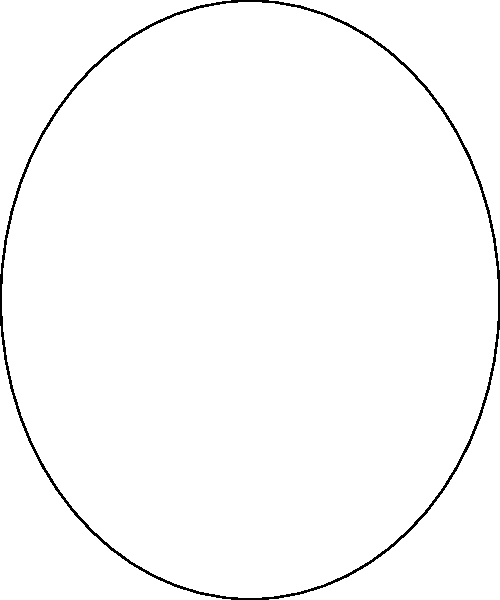In the diagram above, which lighting setup would be most effective for enhancing the depth and texture of prosthetic scars or wounds in a horror film, and why? To determine the most effective lighting setup for enhancing prosthetic scars or wounds in a horror film, we need to consider the properties of each light:

1. Key Light (Red):
   - Main light source
   - Creates strong shadows and highlights
   - Defines the primary contours of the face and prosthetics

2. Fill Light (Blue):
   - Softens shadows created by the key light
   - Reduces contrast and reveals details in shadowed areas

3. Back Light (Green):
   - Separates the subject from the background
   - Creates a rim of light around the edges of the subject

For enhancing the depth and texture of prosthetic scars or wounds:

Step 1: We want to create strong shadows to emphasize depth.
Step 2: The key light (red) is crucial for this as it creates the primary shadows.
Step 3: However, we don't want to completely lose details in the shadows.
Step 4: The fill light (blue) helps reveal some details in the shadowed areas without eliminating the depth created by the key light.
Step 5: The back light (green) is less important for texture but can help separate the subject from a dark background, which is common in horror films.

Therefore, the most effective setup would be to use a strong key light with a subtle fill light. This combination creates deep shadows while still revealing enough detail to showcase the texture of the prosthetics.
Answer: Strong key light with subtle fill light 